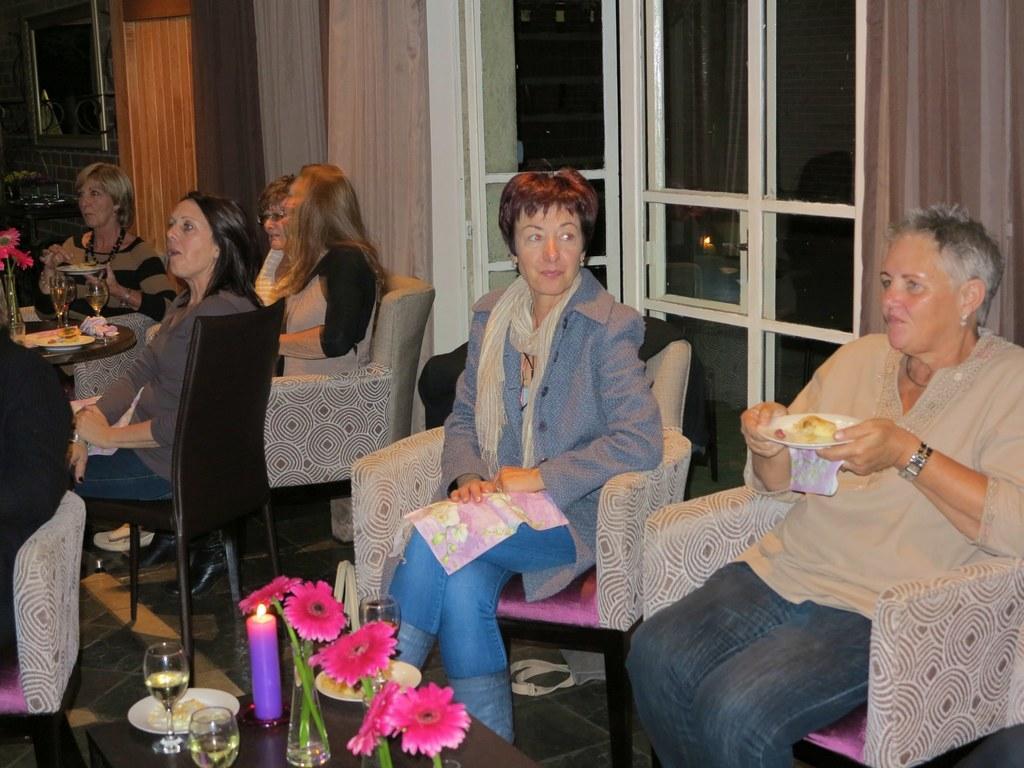Can you describe this image briefly? In this picture we can see some persons sitting on the chairs. There is a table. On the table there are glasses, candle, and flowers. On the background we can see the door. And this is curtain. Here we can see a frame. And this is floor. 